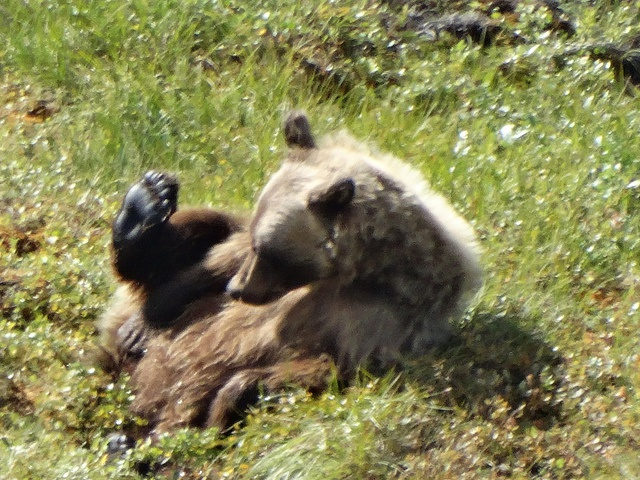Describe the objects in this image and their specific colors. I can see a bear in olive, black, gray, and tan tones in this image. 